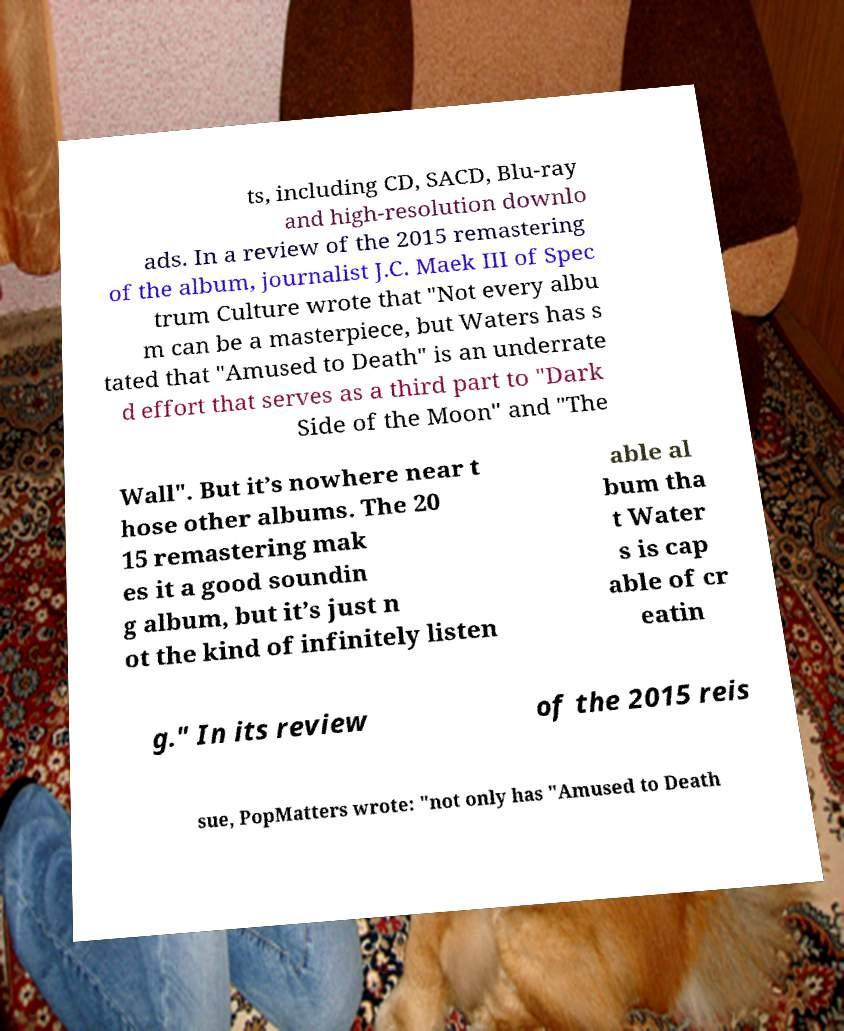What messages or text are displayed in this image? I need them in a readable, typed format. ts, including CD, SACD, Blu-ray and high-resolution downlo ads. In a review of the 2015 remastering of the album, journalist J.C. Maek III of Spec trum Culture wrote that "Not every albu m can be a masterpiece, but Waters has s tated that "Amused to Death" is an underrate d effort that serves as a third part to "Dark Side of the Moon" and "The Wall". But it’s nowhere near t hose other albums. The 20 15 remastering mak es it a good soundin g album, but it’s just n ot the kind of infinitely listen able al bum tha t Water s is cap able of cr eatin g." In its review of the 2015 reis sue, PopMatters wrote: "not only has "Amused to Death 